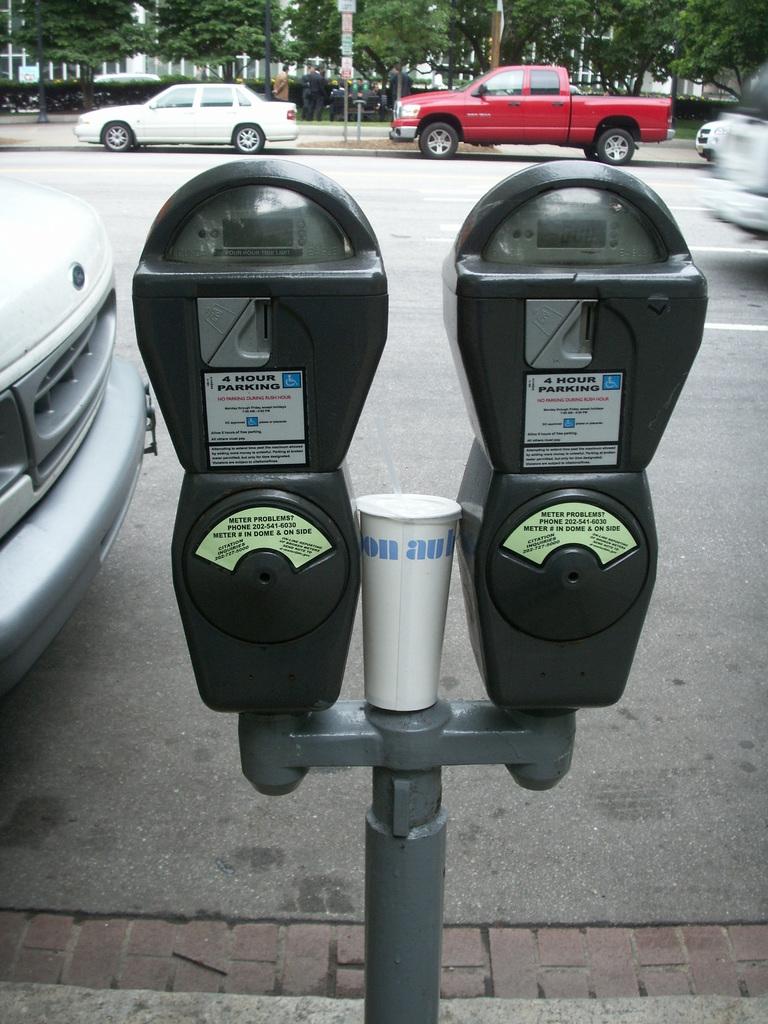How many hours of parking is the meter for?
Provide a short and direct response. 4. What reading is currently on the right meter?
Provide a short and direct response. 000. 